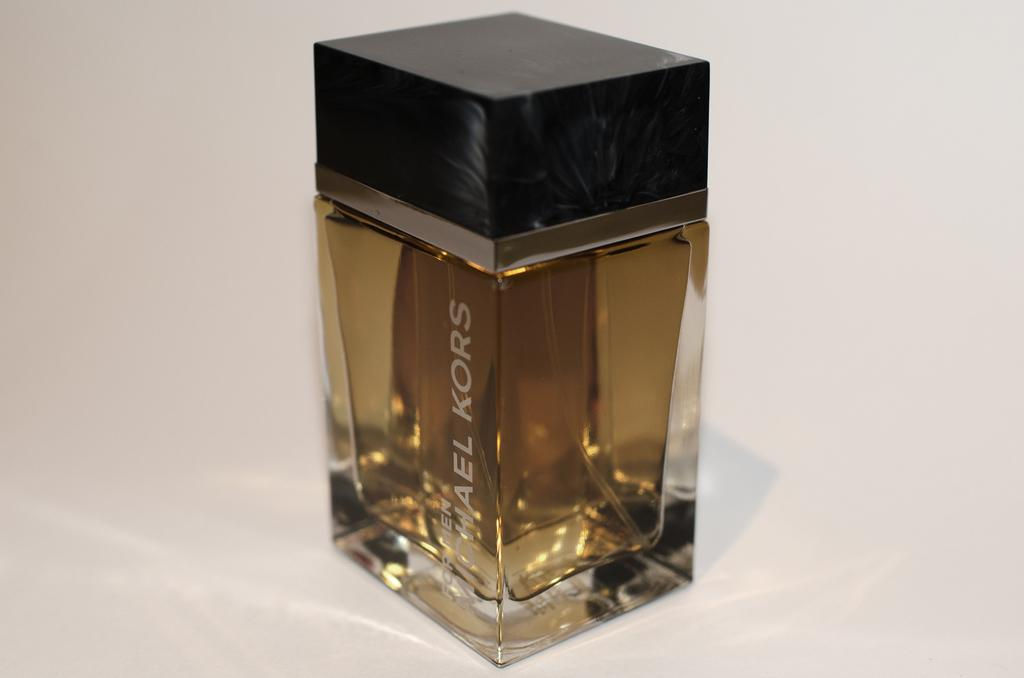<image>
Summarize the visual content of the image. A Michael Kors cologne bottle displayed on table 